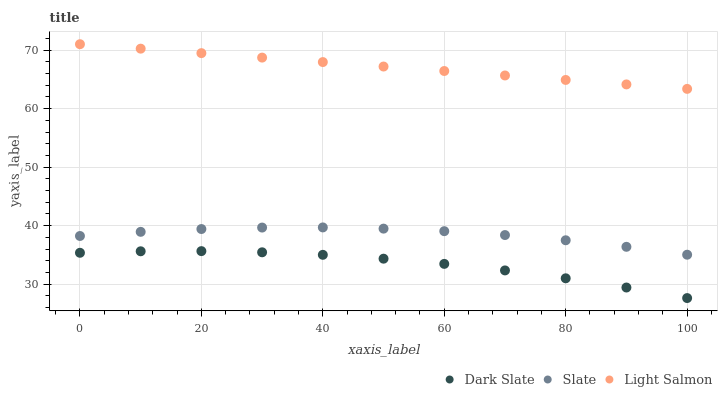Does Dark Slate have the minimum area under the curve?
Answer yes or no. Yes. Does Light Salmon have the maximum area under the curve?
Answer yes or no. Yes. Does Slate have the minimum area under the curve?
Answer yes or no. No. Does Slate have the maximum area under the curve?
Answer yes or no. No. Is Light Salmon the smoothest?
Answer yes or no. Yes. Is Dark Slate the roughest?
Answer yes or no. Yes. Is Slate the smoothest?
Answer yes or no. No. Is Slate the roughest?
Answer yes or no. No. Does Dark Slate have the lowest value?
Answer yes or no. Yes. Does Slate have the lowest value?
Answer yes or no. No. Does Light Salmon have the highest value?
Answer yes or no. Yes. Does Slate have the highest value?
Answer yes or no. No. Is Dark Slate less than Light Salmon?
Answer yes or no. Yes. Is Slate greater than Dark Slate?
Answer yes or no. Yes. Does Dark Slate intersect Light Salmon?
Answer yes or no. No. 